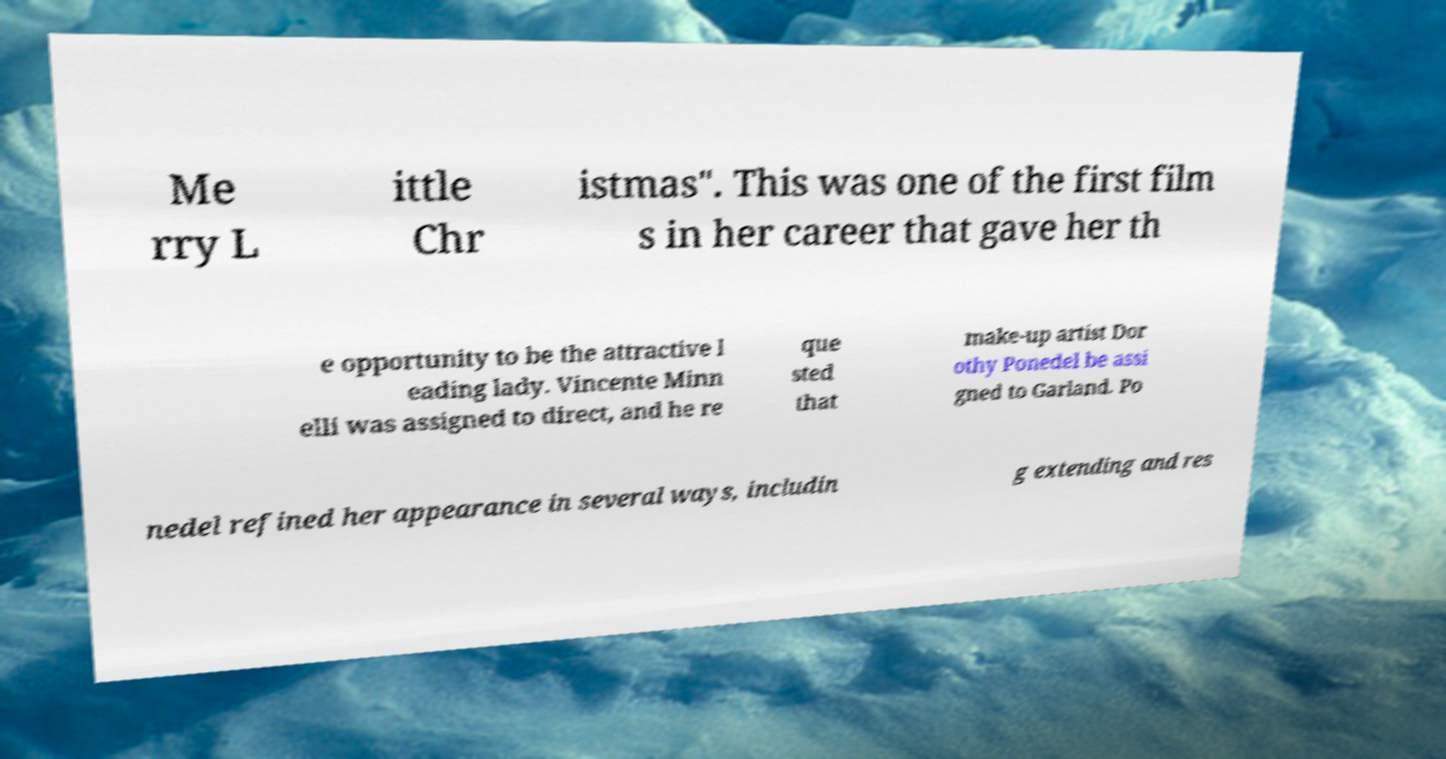Could you extract and type out the text from this image? Me rry L ittle Chr istmas". This was one of the first film s in her career that gave her th e opportunity to be the attractive l eading lady. Vincente Minn elli was assigned to direct, and he re que sted that make-up artist Dor othy Ponedel be assi gned to Garland. Po nedel refined her appearance in several ways, includin g extending and res 